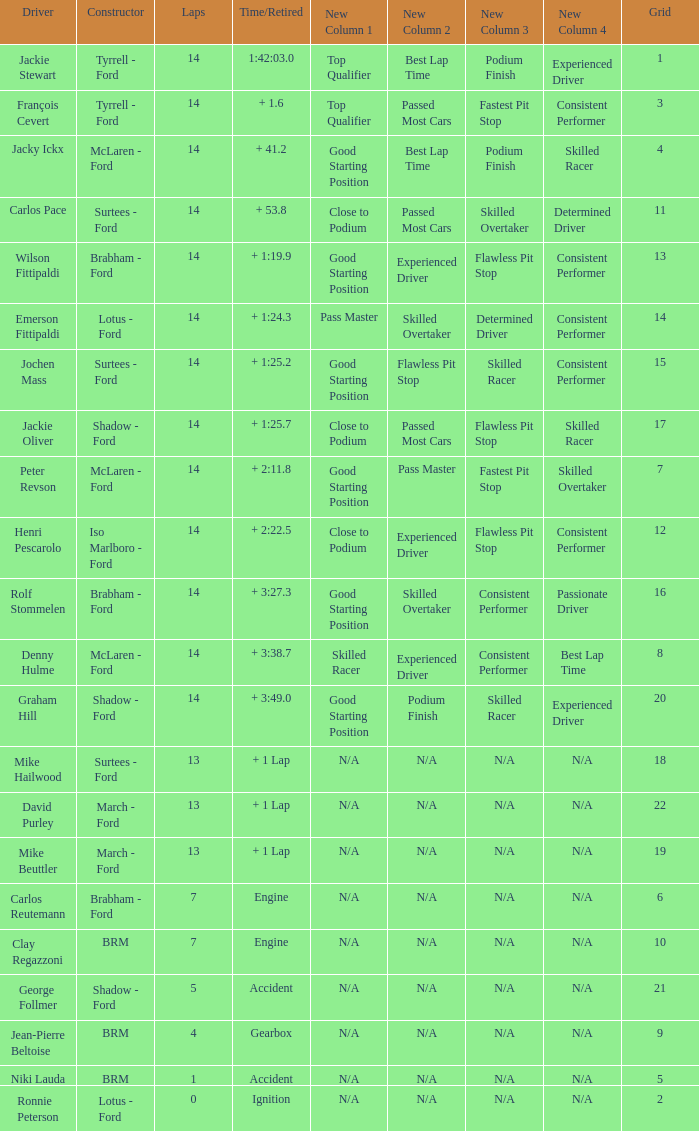What grad has a Time/Retired of + 1:24.3? 14.0. 